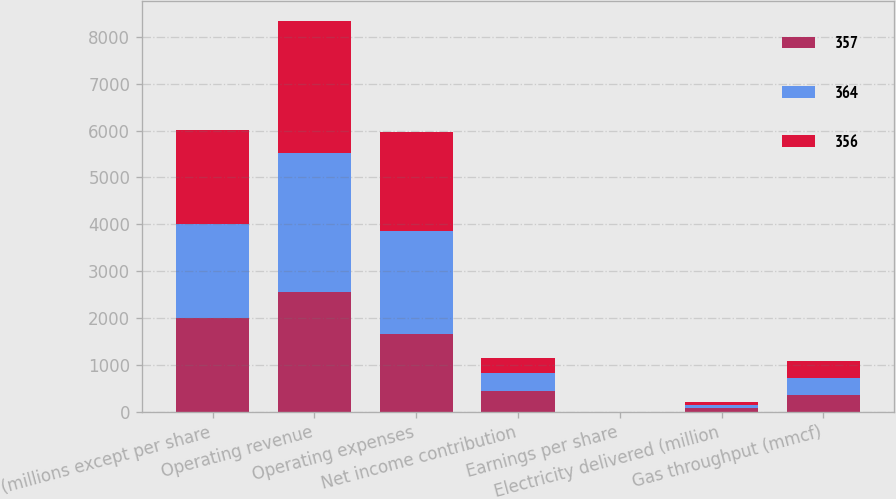<chart> <loc_0><loc_0><loc_500><loc_500><stacked_bar_chart><ecel><fcel>(millions except per share<fcel>Operating revenue<fcel>Operating expenses<fcel>Net income contribution<fcel>Earnings per share<fcel>Electricity delivered (million<fcel>Gas throughput (mmcf)<nl><fcel>357<fcel>2002<fcel>2552<fcel>1653<fcel>455<fcel>1.61<fcel>75<fcel>364<nl><fcel>364<fcel>2001<fcel>2963<fcel>2202<fcel>366<fcel>1.45<fcel>72<fcel>357<nl><fcel>356<fcel>2000<fcel>2826<fcel>2123<fcel>339<fcel>1.43<fcel>74<fcel>356<nl></chart> 